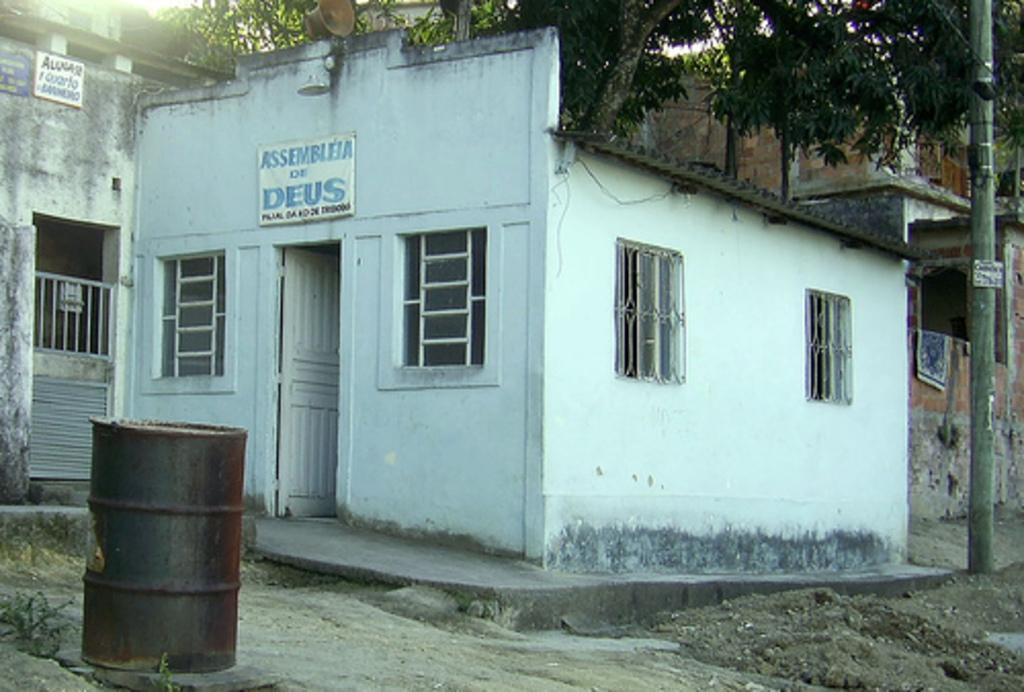Provide a one-sentence caption for the provided image. A small white building says Assembleia of Deus. 